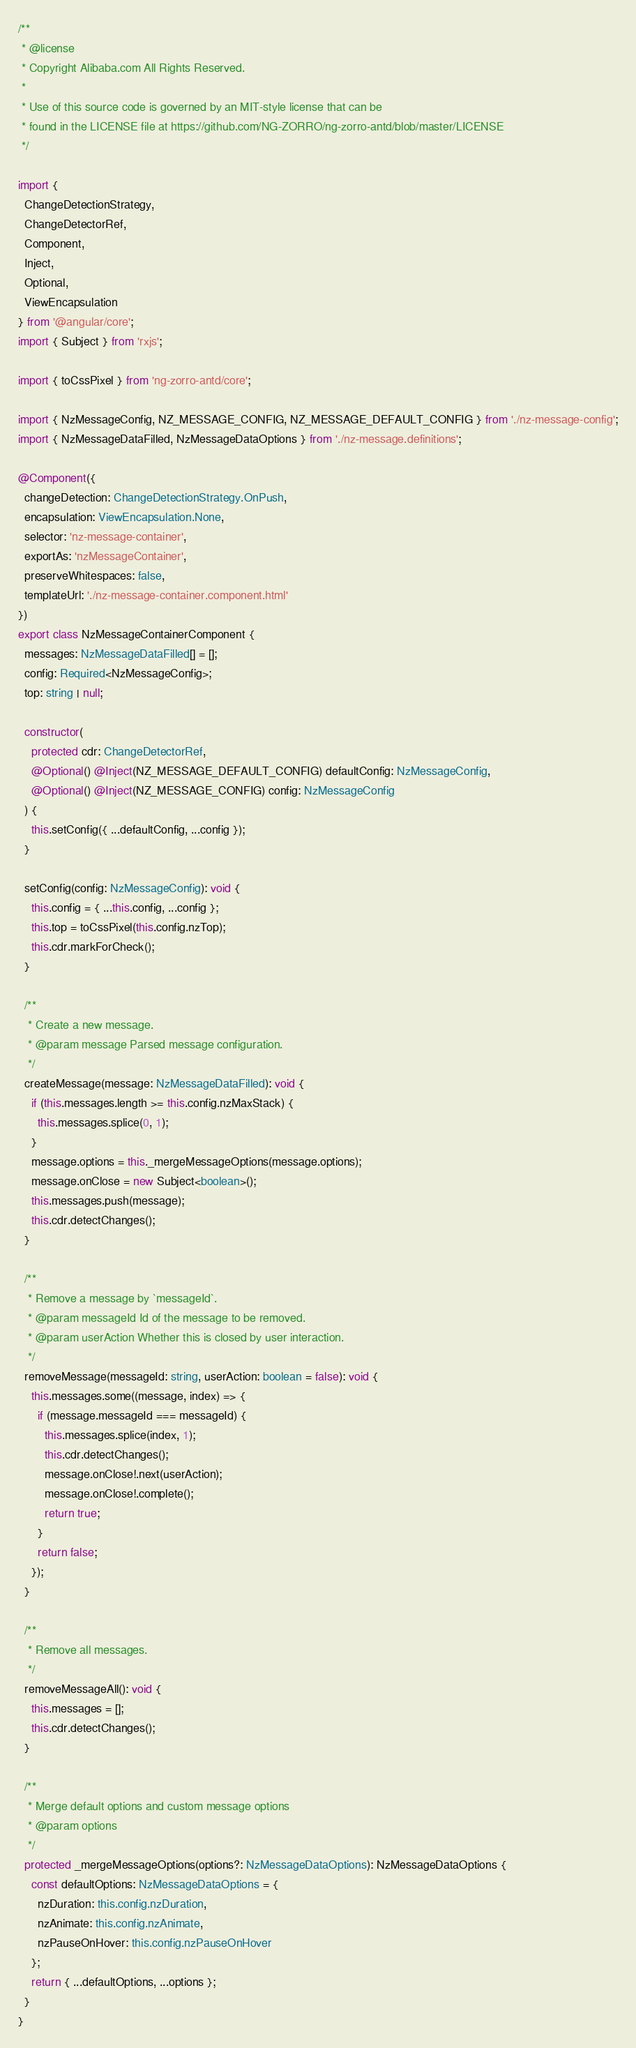<code> <loc_0><loc_0><loc_500><loc_500><_TypeScript_>/**
 * @license
 * Copyright Alibaba.com All Rights Reserved.
 *
 * Use of this source code is governed by an MIT-style license that can be
 * found in the LICENSE file at https://github.com/NG-ZORRO/ng-zorro-antd/blob/master/LICENSE
 */

import {
  ChangeDetectionStrategy,
  ChangeDetectorRef,
  Component,
  Inject,
  Optional,
  ViewEncapsulation
} from '@angular/core';
import { Subject } from 'rxjs';

import { toCssPixel } from 'ng-zorro-antd/core';

import { NzMessageConfig, NZ_MESSAGE_CONFIG, NZ_MESSAGE_DEFAULT_CONFIG } from './nz-message-config';
import { NzMessageDataFilled, NzMessageDataOptions } from './nz-message.definitions';

@Component({
  changeDetection: ChangeDetectionStrategy.OnPush,
  encapsulation: ViewEncapsulation.None,
  selector: 'nz-message-container',
  exportAs: 'nzMessageContainer',
  preserveWhitespaces: false,
  templateUrl: './nz-message-container.component.html'
})
export class NzMessageContainerComponent {
  messages: NzMessageDataFilled[] = [];
  config: Required<NzMessageConfig>;
  top: string | null;

  constructor(
    protected cdr: ChangeDetectorRef,
    @Optional() @Inject(NZ_MESSAGE_DEFAULT_CONFIG) defaultConfig: NzMessageConfig,
    @Optional() @Inject(NZ_MESSAGE_CONFIG) config: NzMessageConfig
  ) {
    this.setConfig({ ...defaultConfig, ...config });
  }

  setConfig(config: NzMessageConfig): void {
    this.config = { ...this.config, ...config };
    this.top = toCssPixel(this.config.nzTop);
    this.cdr.markForCheck();
  }

  /**
   * Create a new message.
   * @param message Parsed message configuration.
   */
  createMessage(message: NzMessageDataFilled): void {
    if (this.messages.length >= this.config.nzMaxStack) {
      this.messages.splice(0, 1);
    }
    message.options = this._mergeMessageOptions(message.options);
    message.onClose = new Subject<boolean>();
    this.messages.push(message);
    this.cdr.detectChanges();
  }

  /**
   * Remove a message by `messageId`.
   * @param messageId Id of the message to be removed.
   * @param userAction Whether this is closed by user interaction.
   */
  removeMessage(messageId: string, userAction: boolean = false): void {
    this.messages.some((message, index) => {
      if (message.messageId === messageId) {
        this.messages.splice(index, 1);
        this.cdr.detectChanges();
        message.onClose!.next(userAction);
        message.onClose!.complete();
        return true;
      }
      return false;
    });
  }

  /**
   * Remove all messages.
   */
  removeMessageAll(): void {
    this.messages = [];
    this.cdr.detectChanges();
  }

  /**
   * Merge default options and custom message options
   * @param options
   */
  protected _mergeMessageOptions(options?: NzMessageDataOptions): NzMessageDataOptions {
    const defaultOptions: NzMessageDataOptions = {
      nzDuration: this.config.nzDuration,
      nzAnimate: this.config.nzAnimate,
      nzPauseOnHover: this.config.nzPauseOnHover
    };
    return { ...defaultOptions, ...options };
  }
}
</code> 